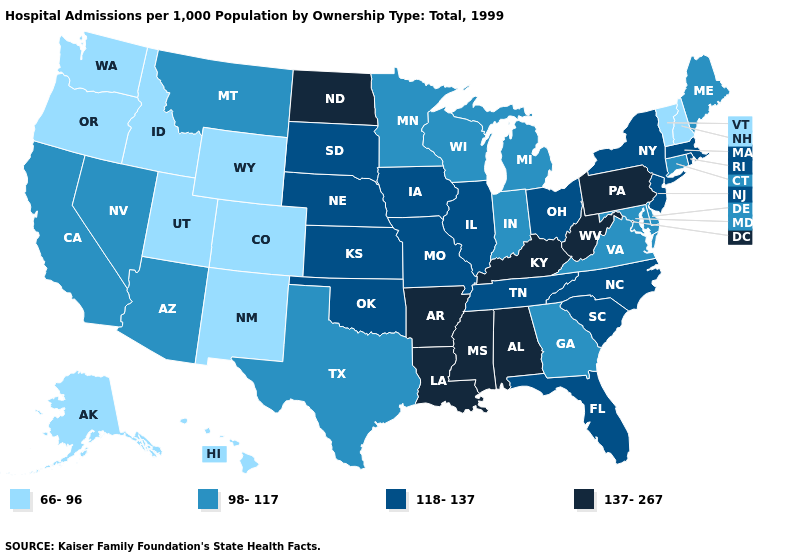Does Michigan have a lower value than Washington?
Be succinct. No. Does Maine have the same value as Virginia?
Give a very brief answer. Yes. Among the states that border Florida , which have the lowest value?
Concise answer only. Georgia. Name the states that have a value in the range 66-96?
Be succinct. Alaska, Colorado, Hawaii, Idaho, New Hampshire, New Mexico, Oregon, Utah, Vermont, Washington, Wyoming. What is the highest value in states that border Florida?
Write a very short answer. 137-267. Name the states that have a value in the range 118-137?
Give a very brief answer. Florida, Illinois, Iowa, Kansas, Massachusetts, Missouri, Nebraska, New Jersey, New York, North Carolina, Ohio, Oklahoma, Rhode Island, South Carolina, South Dakota, Tennessee. Does Virginia have the lowest value in the USA?
Be succinct. No. Name the states that have a value in the range 98-117?
Be succinct. Arizona, California, Connecticut, Delaware, Georgia, Indiana, Maine, Maryland, Michigan, Minnesota, Montana, Nevada, Texas, Virginia, Wisconsin. What is the value of Alabama?
Quick response, please. 137-267. What is the highest value in the MidWest ?
Short answer required. 137-267. Name the states that have a value in the range 137-267?
Keep it brief. Alabama, Arkansas, Kentucky, Louisiana, Mississippi, North Dakota, Pennsylvania, West Virginia. What is the value of Maryland?
Answer briefly. 98-117. Name the states that have a value in the range 66-96?
Quick response, please. Alaska, Colorado, Hawaii, Idaho, New Hampshire, New Mexico, Oregon, Utah, Vermont, Washington, Wyoming. What is the value of South Dakota?
Be succinct. 118-137. Does the map have missing data?
Write a very short answer. No. 